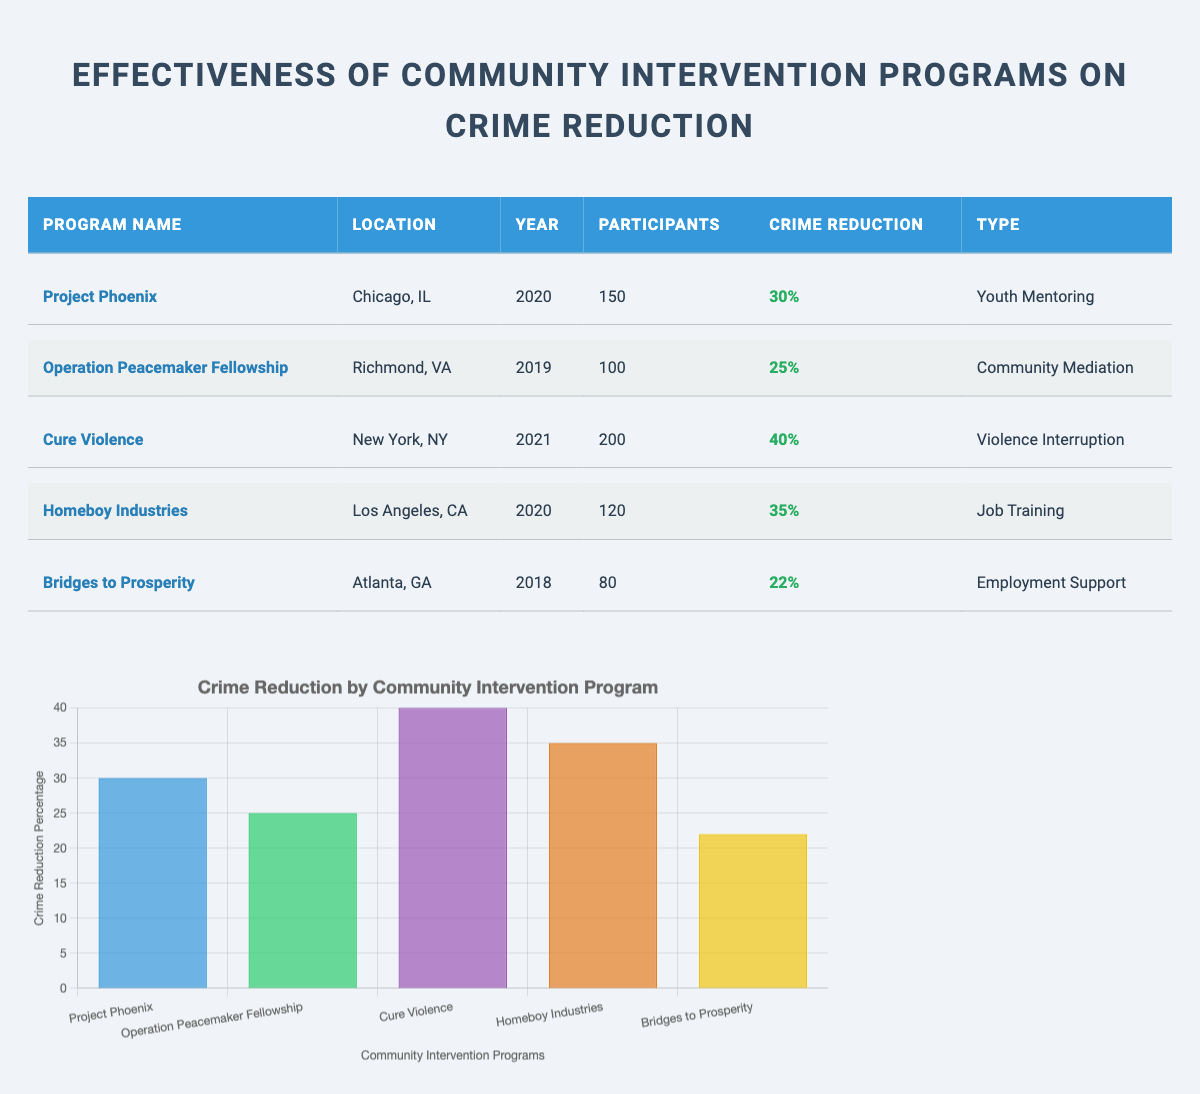What is the name of the program with the highest crime reduction percentage? By inspecting the "Crime Reduction" column of the table, "Cure Violence" has the highest percentage of 40%.
Answer: Cure Violence In which year was "Bridges to Prosperity" conducted? The year can be found in the "Year" column corresponding to the "Bridges to Prosperity" program in the table, which is 2018.
Answer: 2018 How many total participants were involved in all the programs listed? To find the total participants, add the participants from each program: 150 (Project Phoenix) + 100 (Operation Peacemaker Fellowship) + 200 (Cure Violence) + 120 (Homeboy Industries) + 80 (Bridges to Prosperity) = 650.
Answer: 650 Did "Homeboy Industries" have a higher crime reduction percentage than "Operation Peacemaker Fellowship"? Looking at the respective crime reduction percentages, "Homeboy Industries" has 35% and "Operation Peacemaker Fellowship" has 25%. Since 35% is greater than 25%, the statement is true.
Answer: Yes What is the average crime reduction percentage of the listed programs? To calculate the average, sum the percentage values: (30 + 25 + 40 + 35 + 22) = 152, then divide by the number of programs (5). So, 152/5 = 30.4%.
Answer: 30.4% Which type of intervention has the most participants? Checking the "Participants" column, "Cure Violence" has 200 participants, which is the highest number among all programs in the table.
Answer: Violence Interruption How many programs focus on job training? By filtering the "Type" column, only "Homeboy Industries" is categorized under job training, so there’s only one program.
Answer: 1 Which location had the community intervention program with the lowest crime reduction percentage? Comparing the percentages, "Bridges to Prosperity" located in Atlanta, GA, has the lowest at 22%.
Answer: Atlanta, GA 